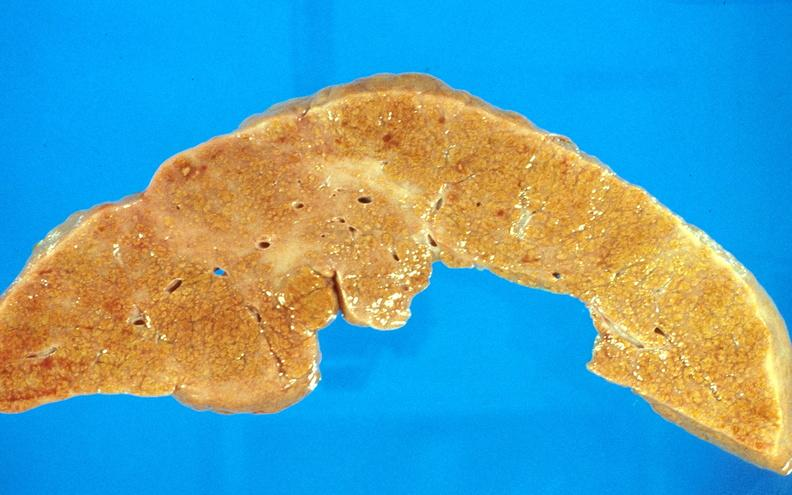what is present?
Answer the question using a single word or phrase. Liver 